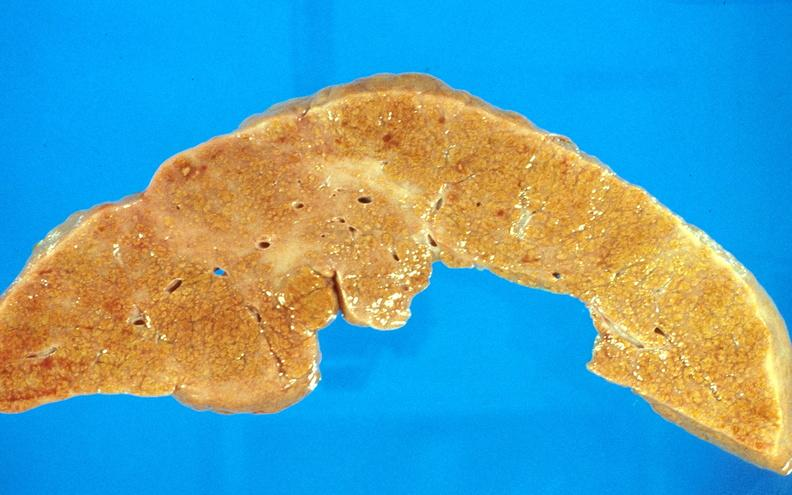what is present?
Answer the question using a single word or phrase. Liver 